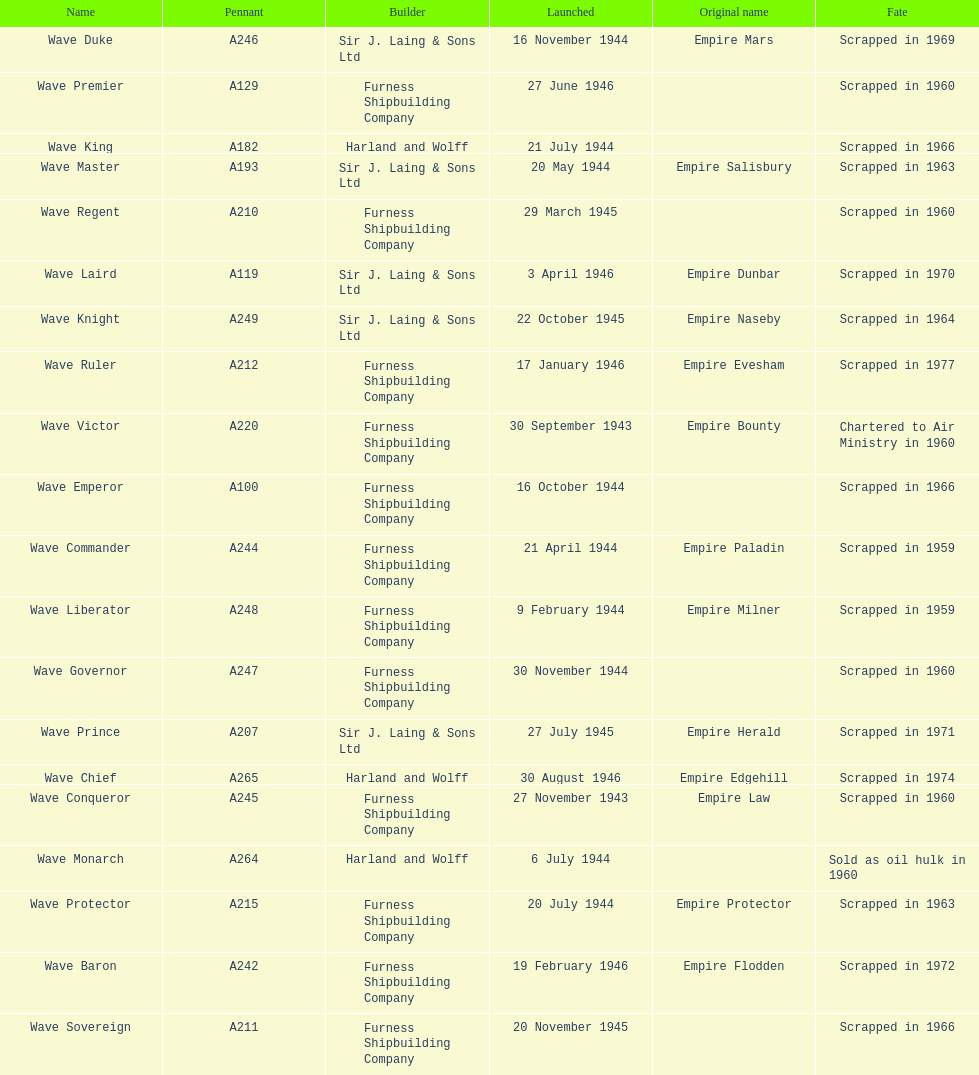What was the next wave class oiler after wave emperor? Wave Duke. 